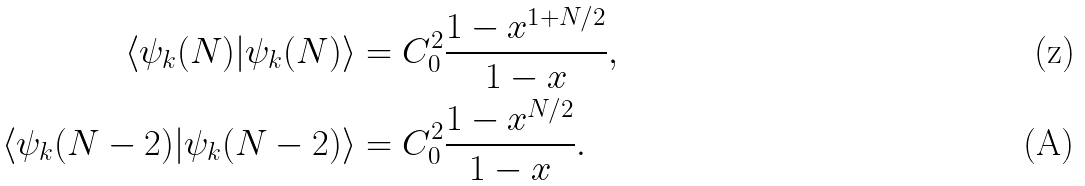<formula> <loc_0><loc_0><loc_500><loc_500>\langle \psi _ { k } ( N ) | \psi _ { k } ( N ) \rangle & = C _ { 0 } ^ { 2 } \frac { 1 - x ^ { 1 + N / 2 } } { 1 - x } , \\ \langle \psi _ { k } ( N - 2 ) | \psi _ { k } ( N - 2 ) \rangle & = C _ { 0 } ^ { 2 } \frac { 1 - x ^ { N / 2 } } { 1 - x } .</formula> 